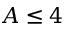Convert formula to latex. <formula><loc_0><loc_0><loc_500><loc_500>A \leq 4</formula> 